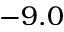<formula> <loc_0><loc_0><loc_500><loc_500>- 9 . 0</formula> 